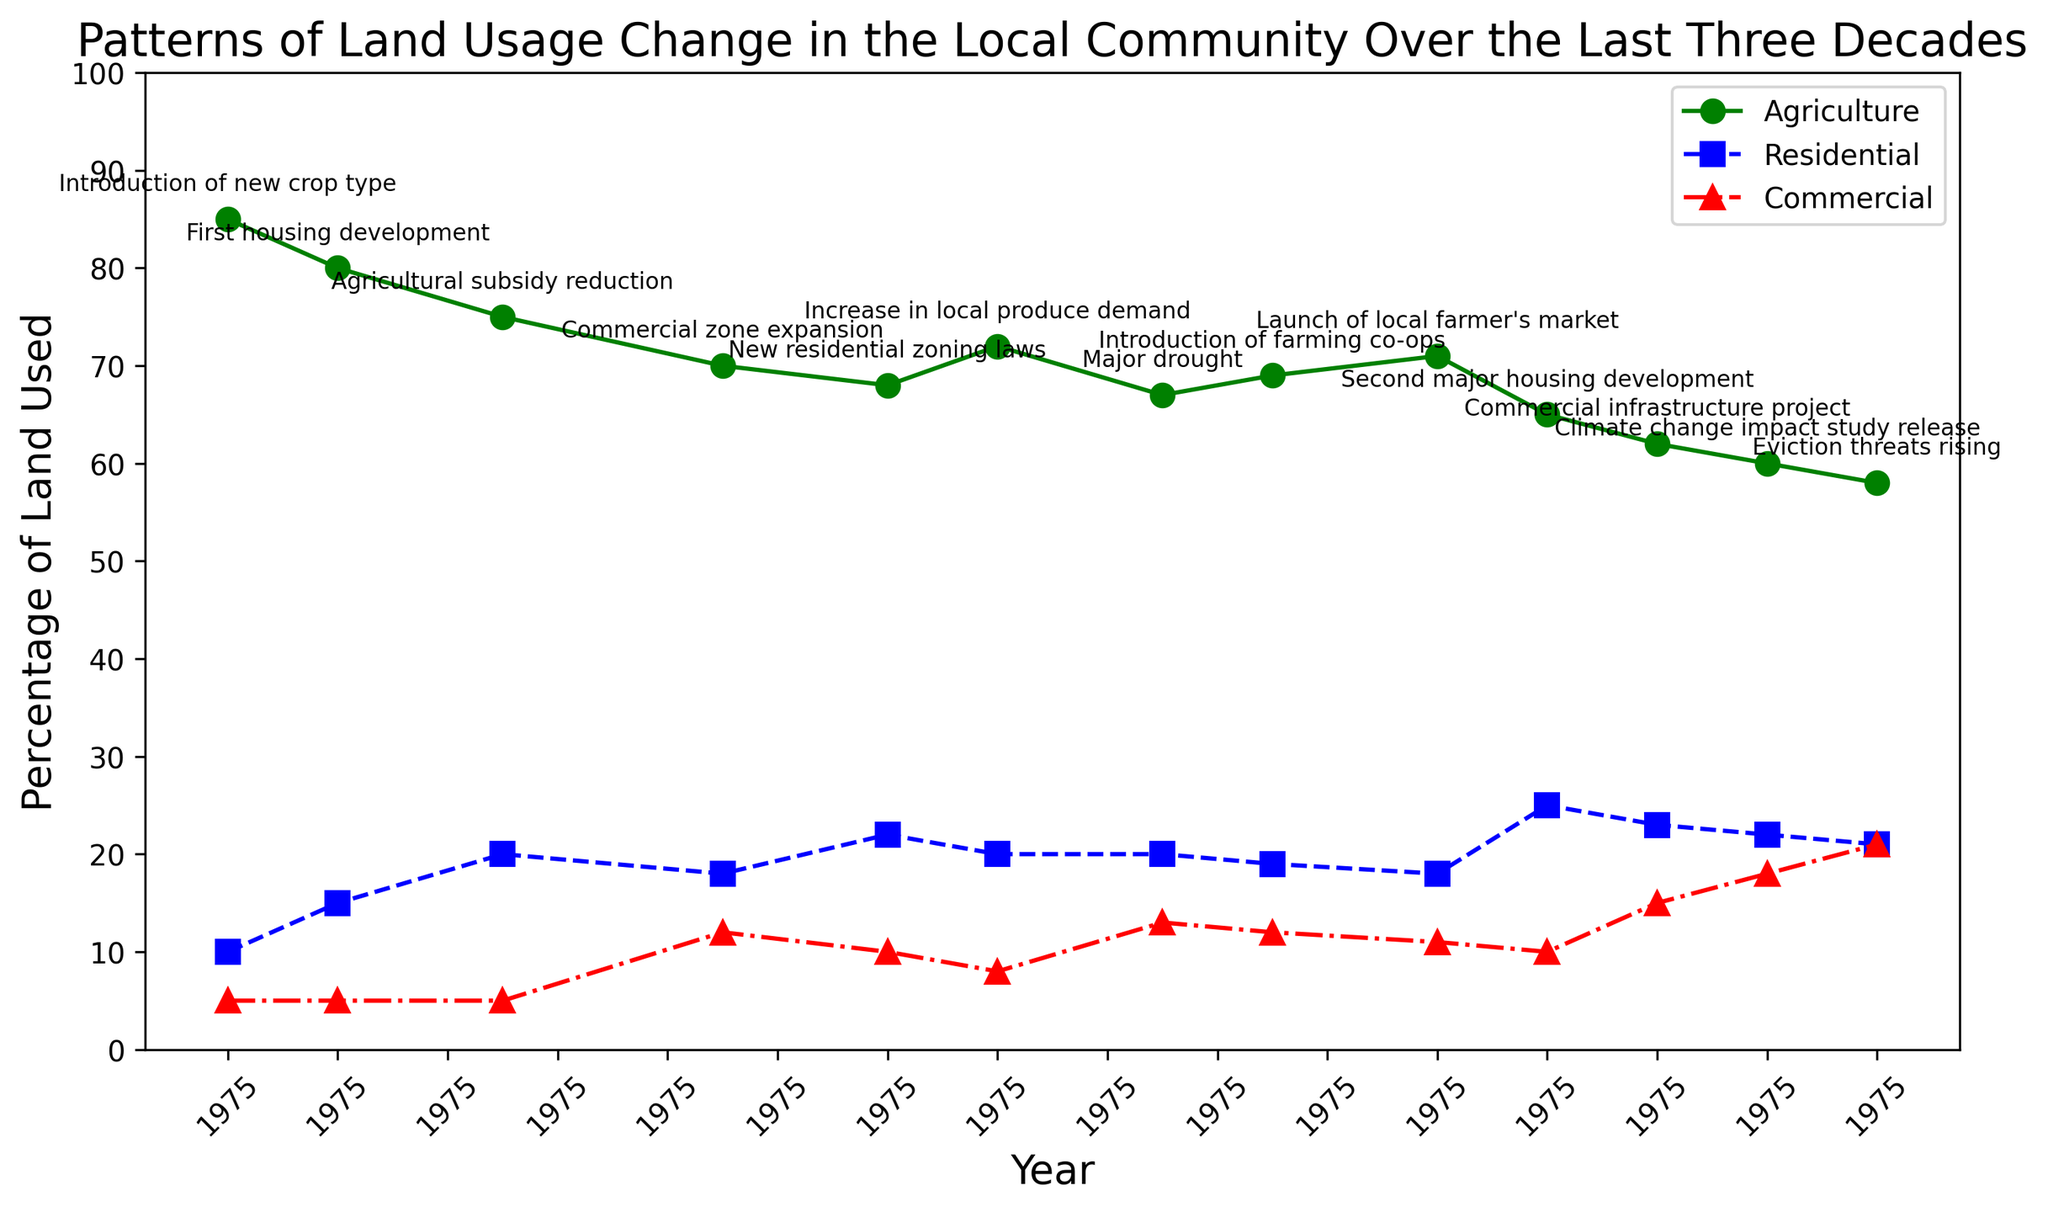What's the trend of land used for agriculture over the years? The green line represents the percentage of land used for agriculture from 1993 to 2023. From the plot, it can be observed that the percentage of land used for agriculture generally decreases over time. Initially, it starts at 85% in 1993 and then follows a downward trend, reaching about 58% in 2023.
Answer: Decreasing Which year had the highest percentage of land used for residential purposes? The blue line represents the percentage of land used for residential purposes. By examining this line, we can see that in 2017, the residential land use peaks at 25%.
Answer: 2017 How does the land usage for commercial purposes change from 2002 to 2023? The red line represents commercial land use. From 2002 onwards, commercial land use increases from 12% to 21% in 2023. This is observably a continual increase in the percentage of land used for commercial purposes.
Answer: Increases What was the difference in agricultural land use between 1995 and 1998? To find the difference, we look at the values for 1995 and 1998 from the green line. In 1995, the agricultural land use is 80%, and in 1998, it is 75%. The difference is 80% - 75% = 5%.
Answer: 5% How did the percentage of agricultural land use change following the major drought in 2010? In 2010, after the major drought, the percentage of agricultural land use was 67%. The following year, 2012, it slightly rose to 69%, indicating a small increase.
Answer: Small increase Between which two years did the land used for residential purposes remain constant? The blue line for residential land use is observed. The residential land use remains at 20% from 2007 to 2010.
Answer: 2007 and 2010 In which year did the agricultural land use experience the most significant single drop, and what was the percentage drop? To find this, we observe the steepest descent in the green line. The largest drop is between 2017 and 2019, where agricultural land use falls from 65% to 62%, a 3% drop.
Answer: 2017-2019, 3% What is the average percentage of land used for commercial purposes from 2002 to 2023? We sum the percentages of commercial land use from 2002 to 2023 and then divide by the number of years. The values are: 12, 10, 8, 13, 12, 11, 10, 15, 18, 21. The sum is 130 and there are 10 values. So, the average is 130/10 = 13%.
Answer: 13% How did the introduction of farming co-ops in 2012 affect agricultural land use? Following the introduction of farming co-ops in 2012, the percentage of land used for agriculture slightly increases from 67% in 2010 to 69% in 2012.
Answer: Increased Compare the percentage of agricultural and commercial land use in 2023. Which is higher, and by how much? In 2023, observe the green and red lines. Agricultural land use is 58%, and commercial land use is 21%. The agricultural land use is higher by 58% - 21% = 37%.
Answer: Agricultural, 37% 